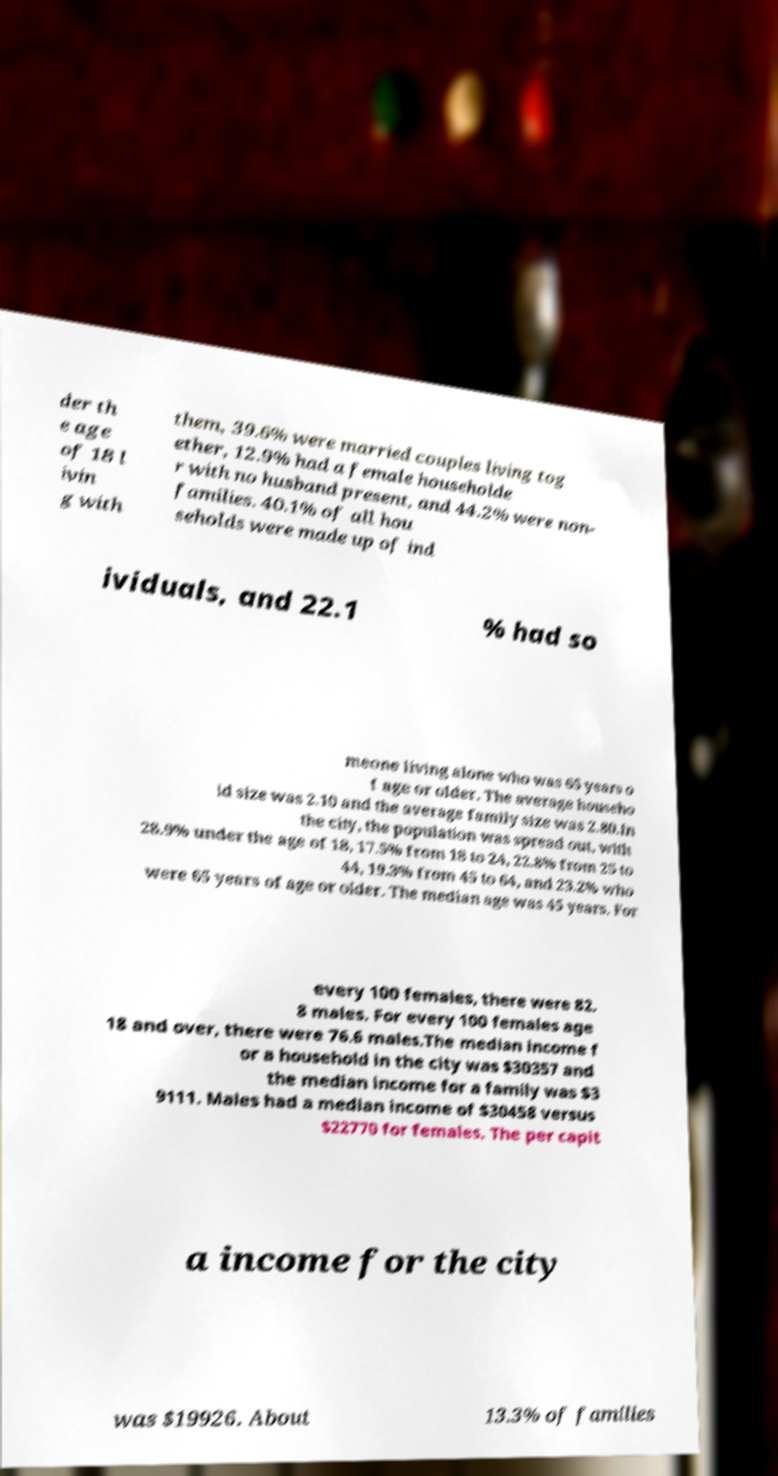What messages or text are displayed in this image? I need them in a readable, typed format. der th e age of 18 l ivin g with them, 39.6% were married couples living tog ether, 12.9% had a female householde r with no husband present, and 44.2% were non- families. 40.1% of all hou seholds were made up of ind ividuals, and 22.1 % had so meone living alone who was 65 years o f age or older. The average househo ld size was 2.10 and the average family size was 2.80.In the city, the population was spread out, with 28.9% under the age of 18, 17.5% from 18 to 24, 22.8% from 25 to 44, 19.3% from 45 to 64, and 23.2% who were 65 years of age or older. The median age was 45 years. For every 100 females, there were 82. 8 males. For every 100 females age 18 and over, there were 76.6 males.The median income f or a household in the city was $30357 and the median income for a family was $3 9111. Males had a median income of $30458 versus $22770 for females. The per capit a income for the city was $19926. About 13.3% of families 